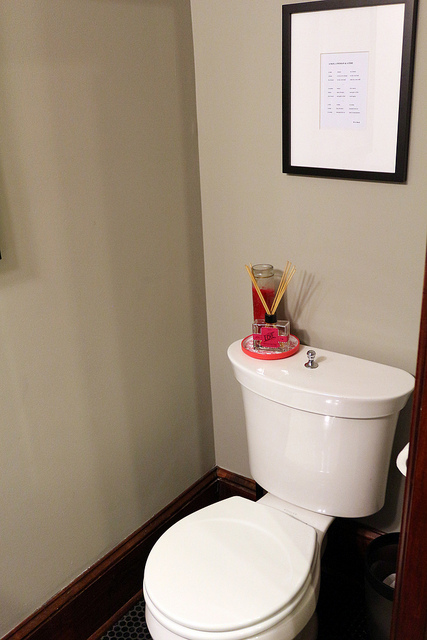How many toilets are there? 2 